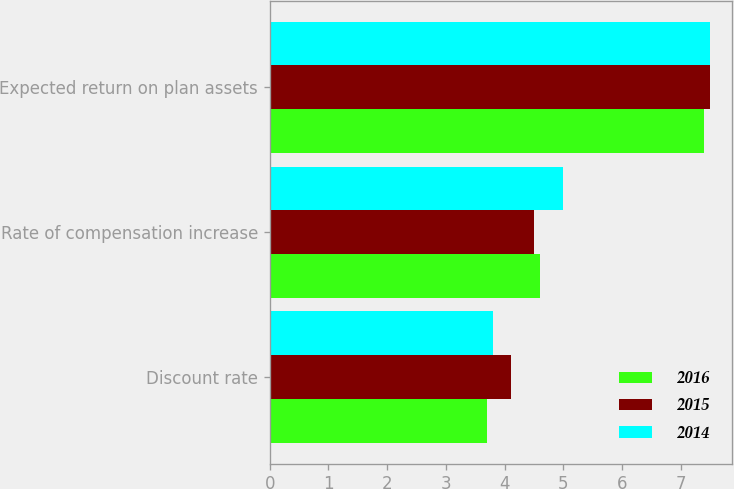Convert chart to OTSL. <chart><loc_0><loc_0><loc_500><loc_500><stacked_bar_chart><ecel><fcel>Discount rate<fcel>Rate of compensation increase<fcel>Expected return on plan assets<nl><fcel>2016<fcel>3.7<fcel>4.6<fcel>7.4<nl><fcel>2015<fcel>4.1<fcel>4.5<fcel>7.5<nl><fcel>2014<fcel>3.8<fcel>5<fcel>7.5<nl></chart> 